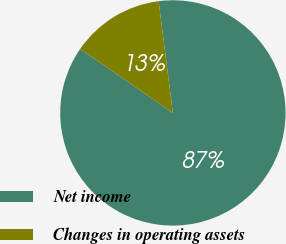<chart> <loc_0><loc_0><loc_500><loc_500><pie_chart><fcel>Net income<fcel>Changes in operating assets<nl><fcel>86.63%<fcel>13.37%<nl></chart> 